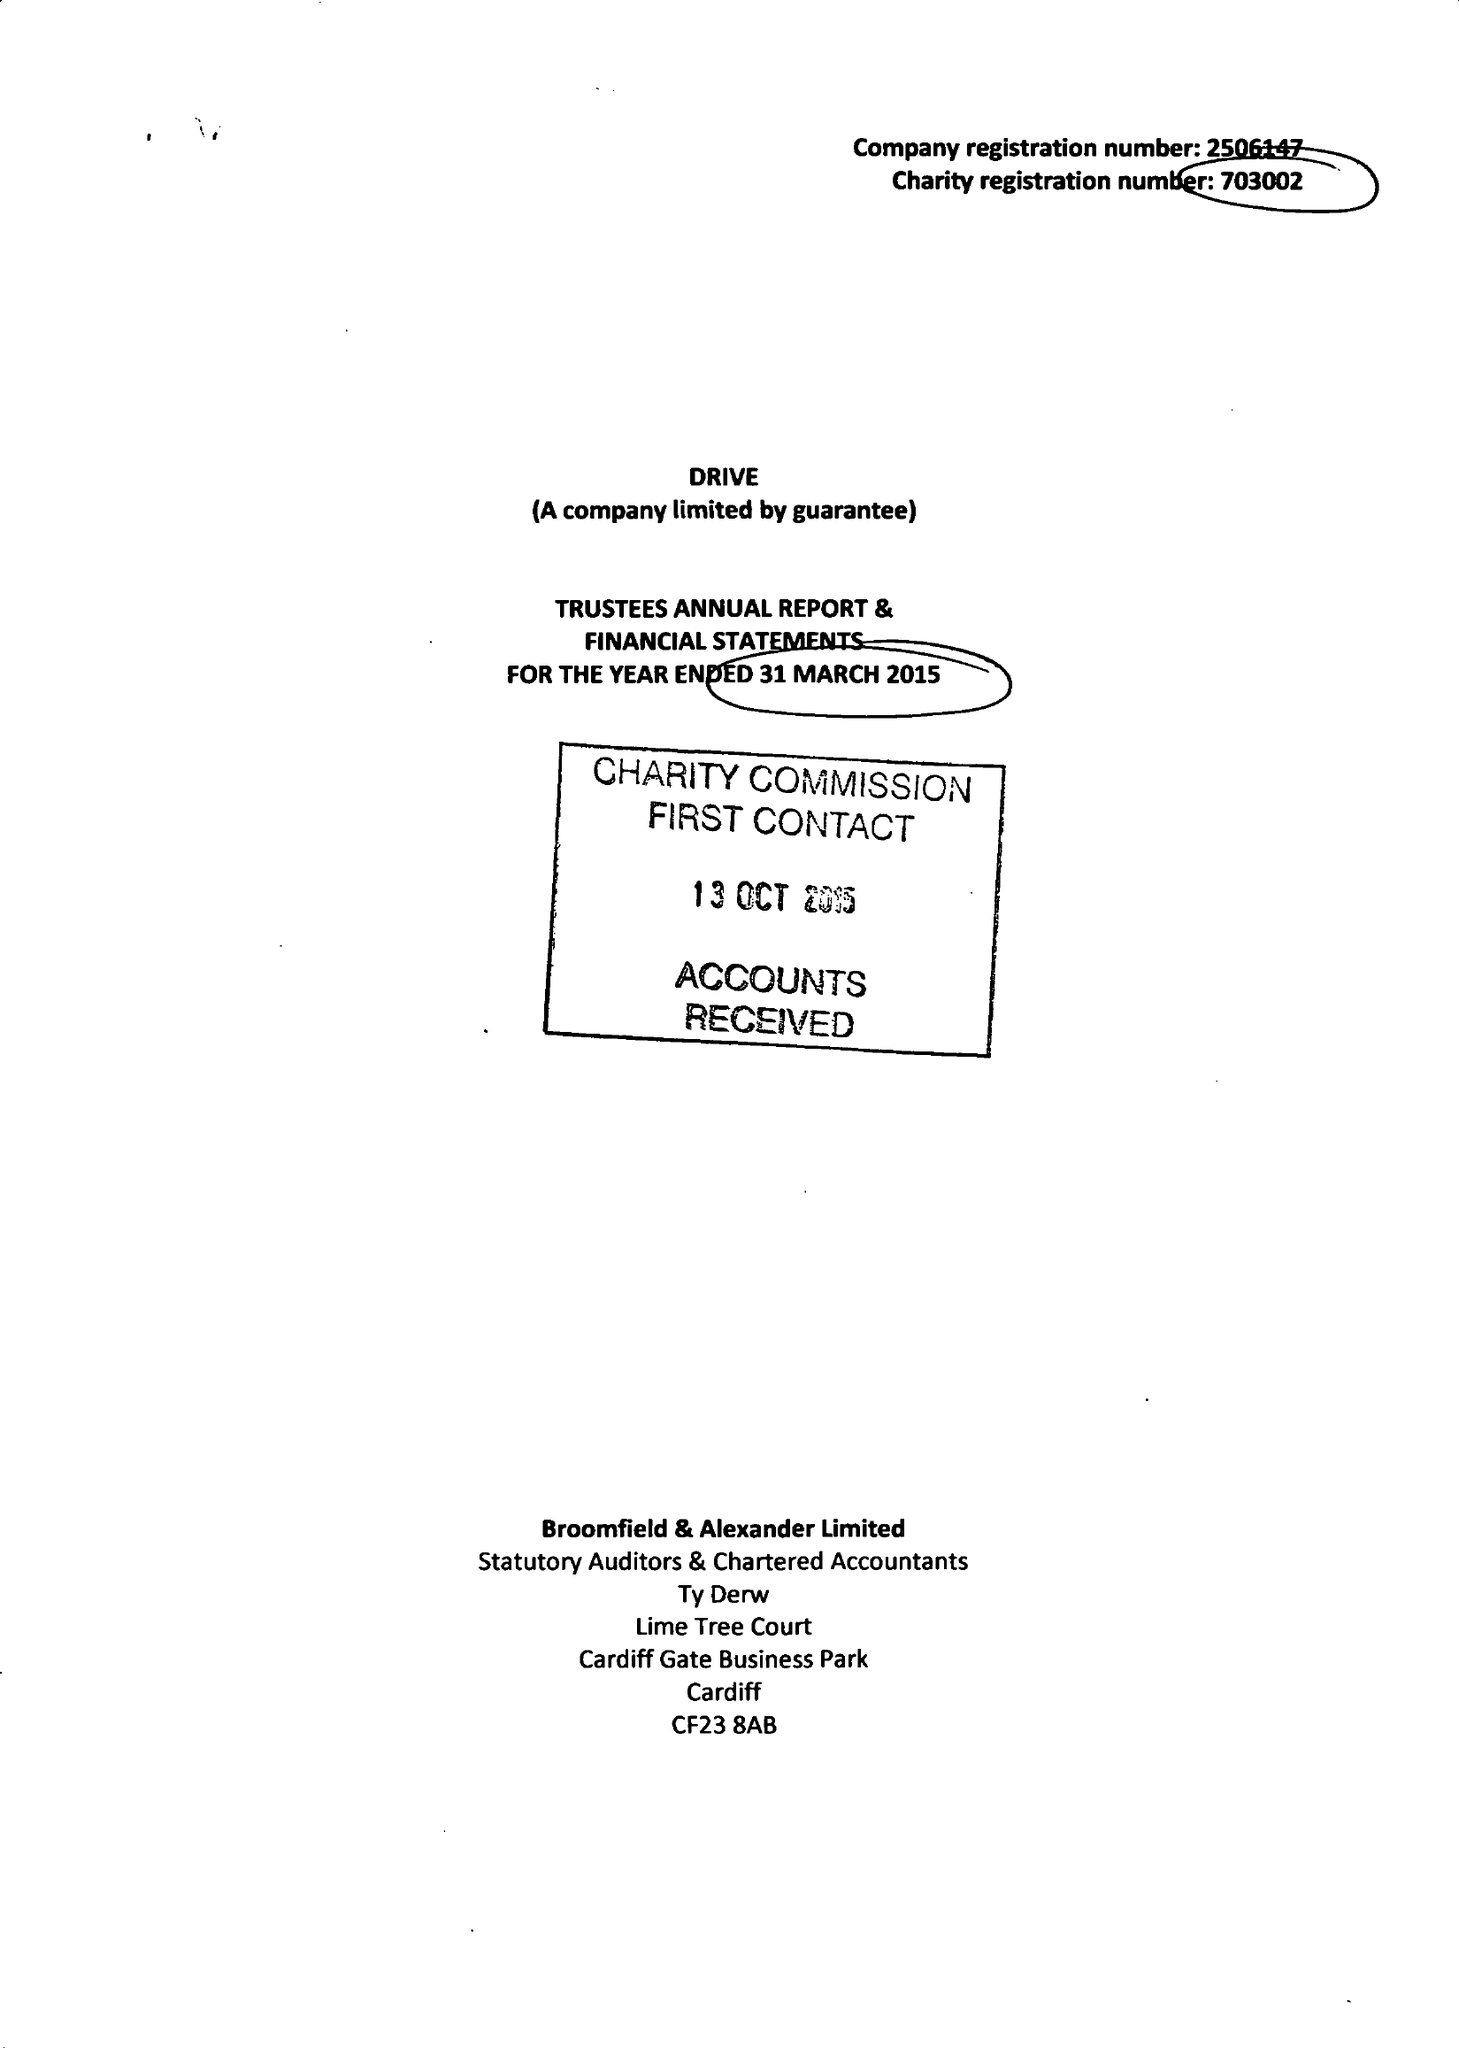What is the value for the address__postcode?
Answer the question using a single word or phrase. CF15 7QQ 